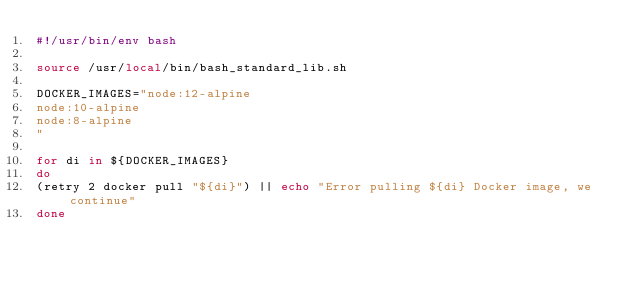Convert code to text. <code><loc_0><loc_0><loc_500><loc_500><_Bash_>#!/usr/bin/env bash

source /usr/local/bin/bash_standard_lib.sh

DOCKER_IMAGES="node:12-alpine
node:10-alpine
node:8-alpine
"

for di in ${DOCKER_IMAGES}
do
(retry 2 docker pull "${di}") || echo "Error pulling ${di} Docker image, we continue"
done

</code> 